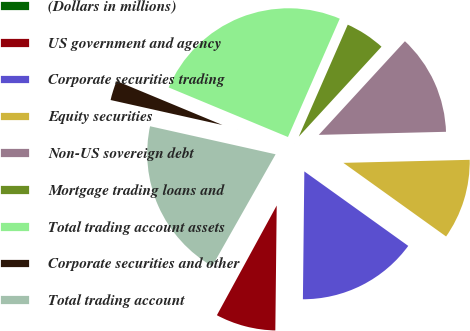Convert chart. <chart><loc_0><loc_0><loc_500><loc_500><pie_chart><fcel>(Dollars in millions)<fcel>US government and agency<fcel>Corporate securities trading<fcel>Equity securities<fcel>Non-US sovereign debt<fcel>Mortgage trading loans and<fcel>Total trading account assets<fcel>Corporate securities and other<fcel>Total trading account<nl><fcel>0.26%<fcel>7.77%<fcel>15.28%<fcel>10.28%<fcel>12.78%<fcel>5.27%<fcel>25.3%<fcel>2.77%<fcel>20.29%<nl></chart> 